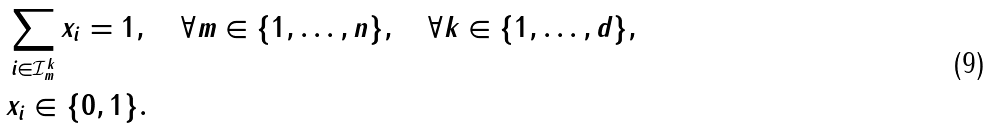Convert formula to latex. <formula><loc_0><loc_0><loc_500><loc_500>& \sum _ { i \in \mathcal { I } ^ { k } _ { m } } x _ { i } = 1 , \quad \forall m \in \{ 1 , \dots , n \} , \quad \forall k \in \{ 1 , \dots , d \} , \\ & x _ { i } \in \{ 0 , 1 \} .</formula> 